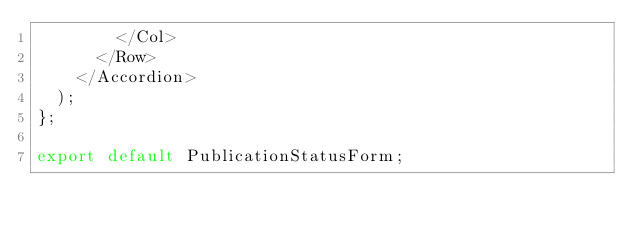<code> <loc_0><loc_0><loc_500><loc_500><_JavaScript_>        </Col>
      </Row>
    </Accordion>
  );
};

export default PublicationStatusForm;
</code> 